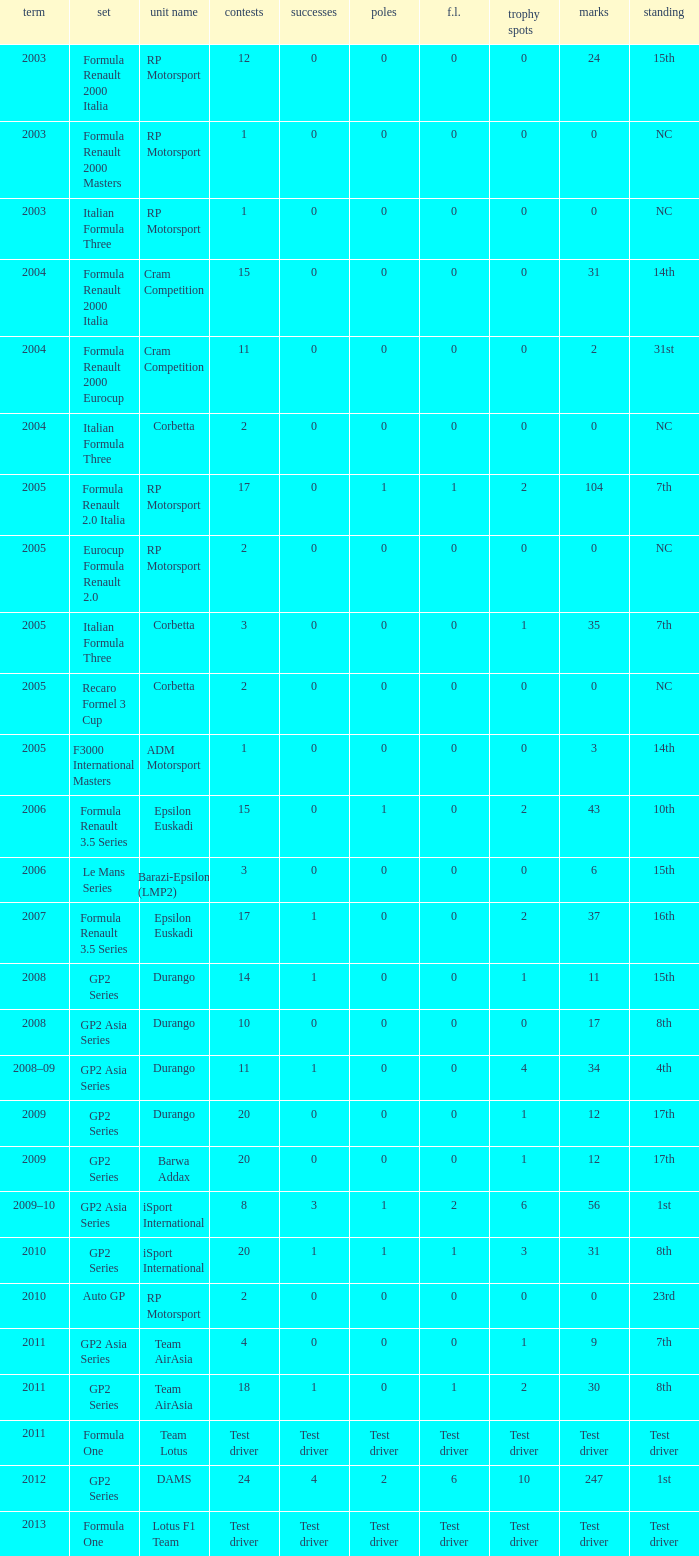What races have gp2 series, 0 F.L. and a 17th position? 20, 20. 